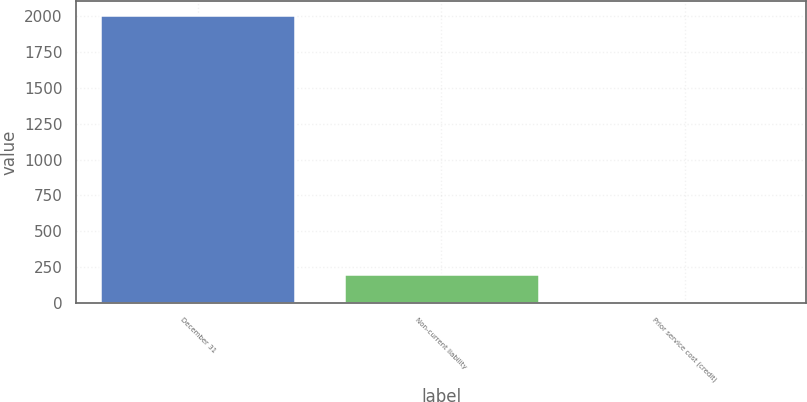<chart> <loc_0><loc_0><loc_500><loc_500><bar_chart><fcel>December 31<fcel>Non-current liability<fcel>Prior service cost (credit)<nl><fcel>2006<fcel>201.41<fcel>0.9<nl></chart> 